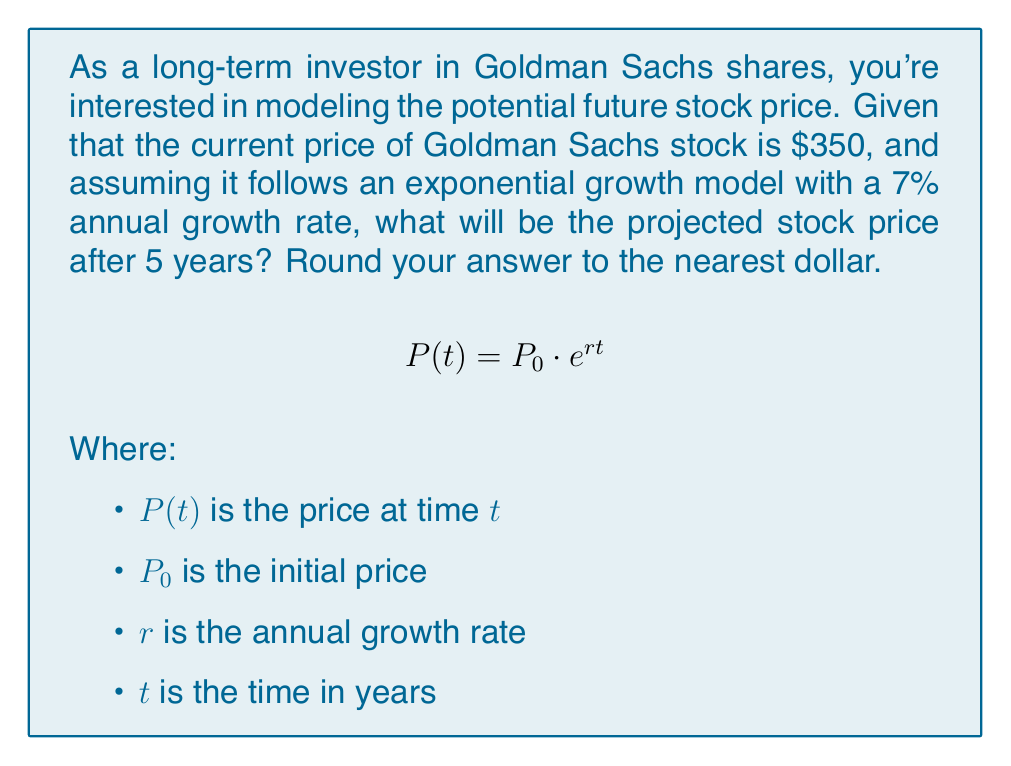Solve this math problem. To solve this problem, we'll use the exponential growth model formula:

$$P(t) = P_0 \cdot e^{rt}$$

Given:
$P_0 = 350$ (initial price)
$r = 0.07$ (7% annual growth rate)
$t = 5$ years

Let's substitute these values into the formula:

$$P(5) = 350 \cdot e^{0.07 \cdot 5}$$

Now, let's calculate step by step:

1) First, simplify the exponent:
   $$P(5) = 350 \cdot e^{0.35}$$

2) Calculate $e^{0.35}$ using a calculator:
   $$e^{0.35} \approx 1.4191$$

3) Multiply this by the initial price:
   $$P(5) = 350 \cdot 1.4191 \approx 496.685$$

4) Round to the nearest dollar:
   $$P(5) \approx 497$$

Therefore, the projected stock price after 5 years is approximately $497.
Answer: $497 